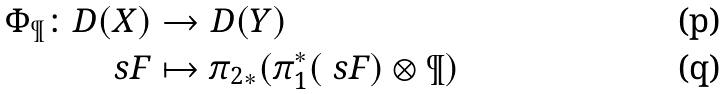<formula> <loc_0><loc_0><loc_500><loc_500>\Phi _ { \P } \colon D ( X ) & \rightarrow D ( Y ) \\ \ s F & \mapsto { \pi _ { 2 } } _ { * } ( \pi _ { 1 } ^ { * } ( \ s F ) \otimes \P )</formula> 